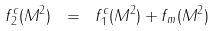<formula> <loc_0><loc_0><loc_500><loc_500>f _ { 2 } ^ { c } ( M ^ { 2 } ) \ = \ f _ { 1 } ^ { c } ( M ^ { 2 } ) + f _ { m } ( M ^ { 2 } )</formula> 